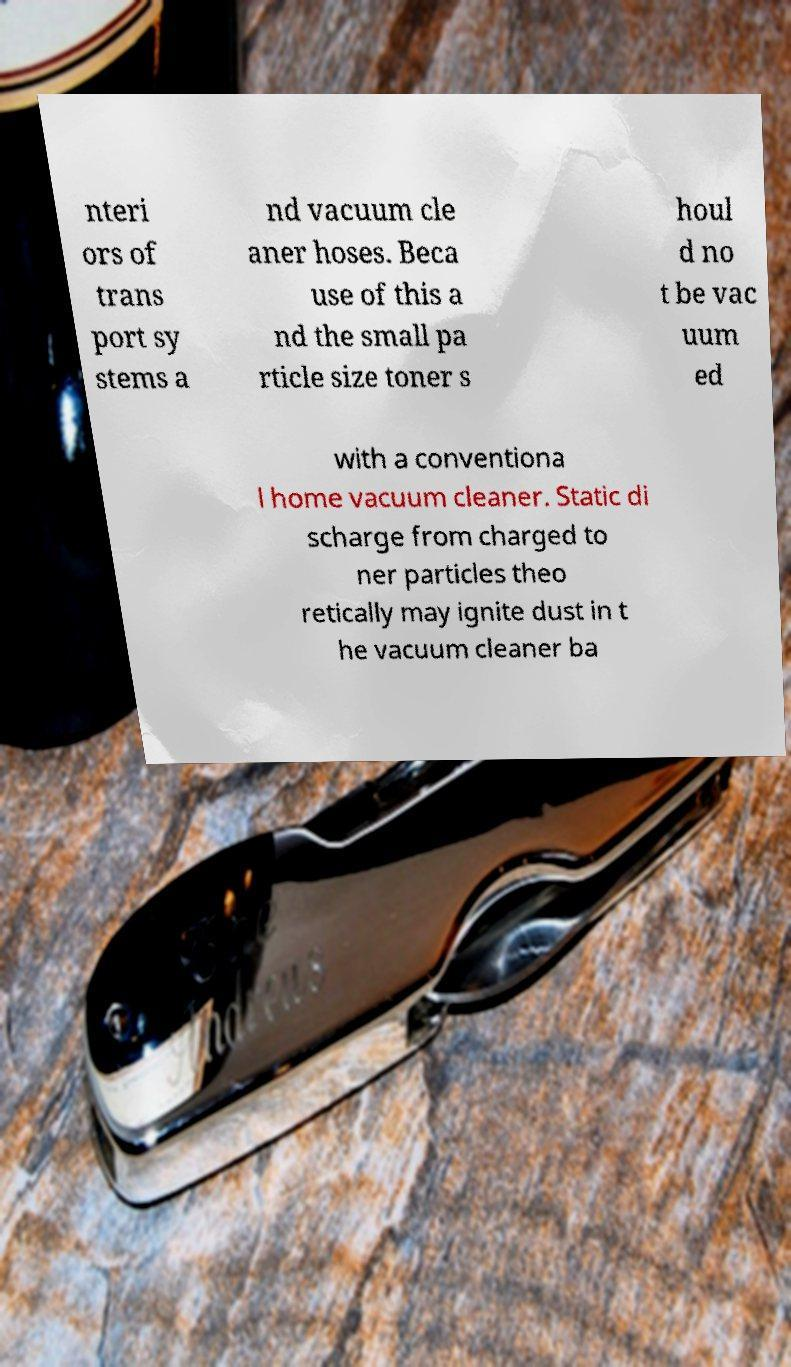Can you accurately transcribe the text from the provided image for me? nteri ors of trans port sy stems a nd vacuum cle aner hoses. Beca use of this a nd the small pa rticle size toner s houl d no t be vac uum ed with a conventiona l home vacuum cleaner. Static di scharge from charged to ner particles theo retically may ignite dust in t he vacuum cleaner ba 